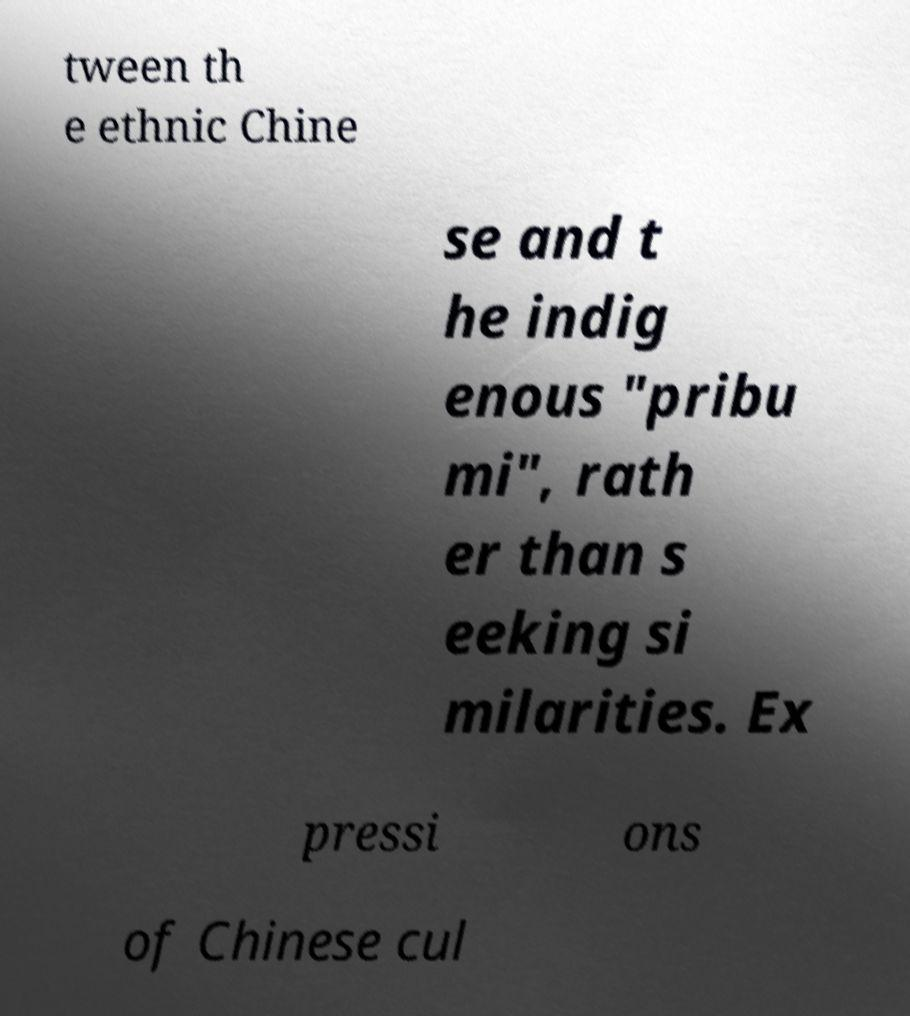Please read and relay the text visible in this image. What does it say? tween th e ethnic Chine se and t he indig enous "pribu mi", rath er than s eeking si milarities. Ex pressi ons of Chinese cul 